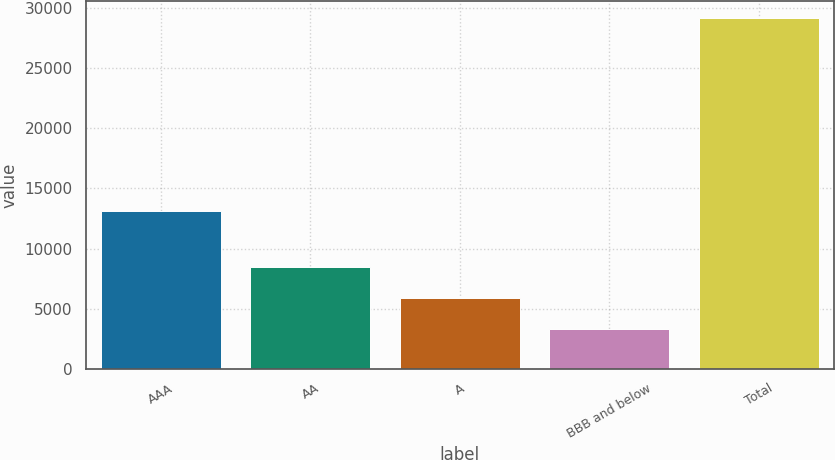Convert chart. <chart><loc_0><loc_0><loc_500><loc_500><bar_chart><fcel>AAA<fcel>AA<fcel>A<fcel>BBB and below<fcel>Total<nl><fcel>13100<fcel>8473.2<fcel>5889.1<fcel>3305<fcel>29146<nl></chart> 